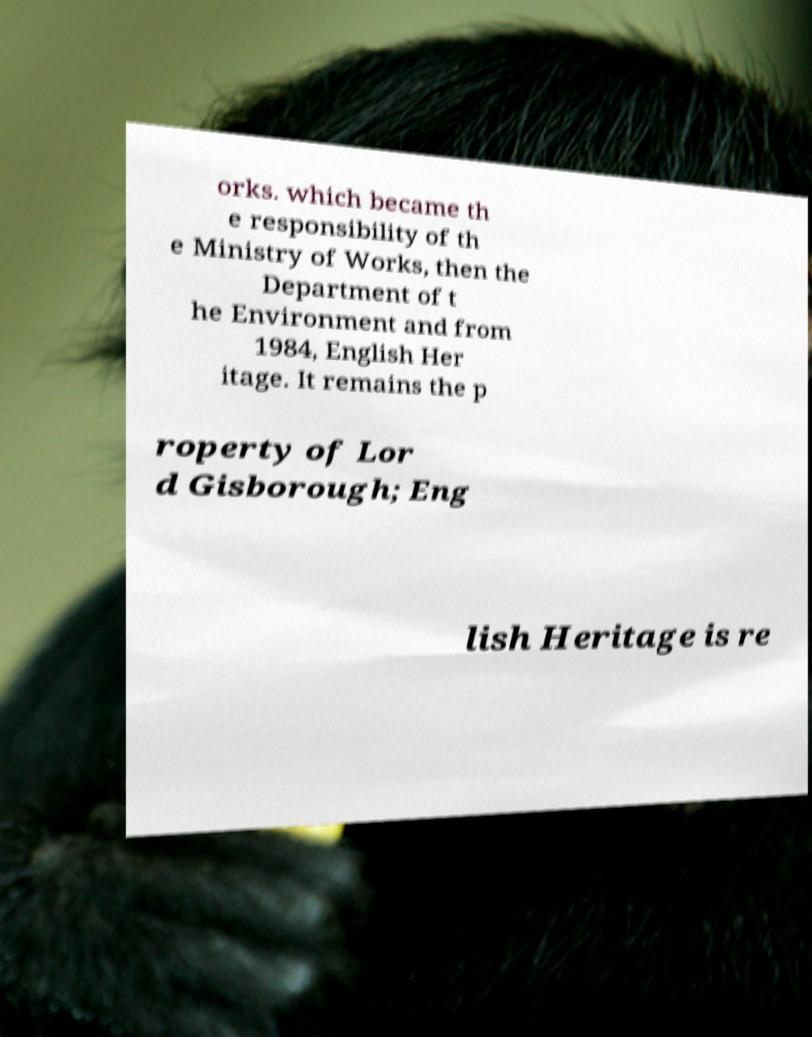Please read and relay the text visible in this image. What does it say? orks. which became th e responsibility of th e Ministry of Works, then the Department of t he Environment and from 1984, English Her itage. It remains the p roperty of Lor d Gisborough; Eng lish Heritage is re 